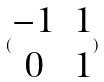Convert formula to latex. <formula><loc_0><loc_0><loc_500><loc_500>( \begin{matrix} - 1 & 1 \\ 0 & 1 \end{matrix} )</formula> 